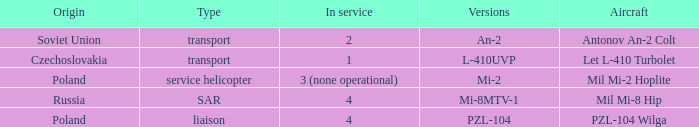Tell me the aircraft for pzl-104 PZL-104 Wilga. 